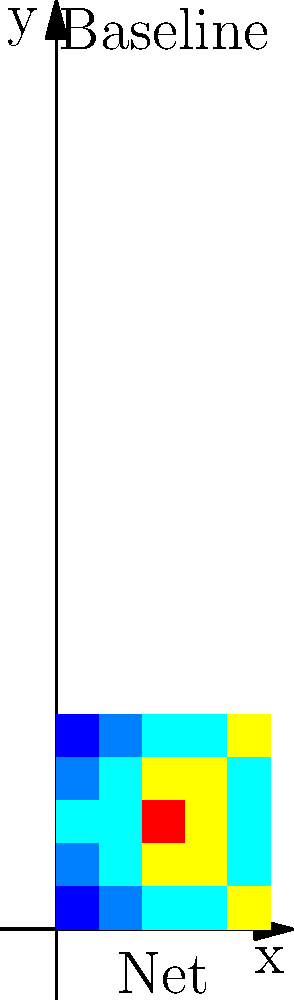Given the heat map of player movements on a badminton court, where warmer colors (red) indicate higher frequency of movement and cooler colors (blue) indicate lower frequency, what strategy would you recommend to optimize court coverage based on this data? To optimize court coverage based on the given heat map, we need to analyze the movement patterns and devise a strategy accordingly. Let's break it down step-by-step:

1. Analyze the heat map:
   - The center of the court (represented by the 3x3 square in the middle) shows the highest concentration of movement (red and yellow).
   - The front corners near the net and the back corners near the baseline show less frequent movement (light blue).

2. Interpret the data:
   - The player spends most of their time in the central area of the court.
   - There's moderate movement towards the sides of the court in the mid-court area.
   - The corners are visited less frequently.

3. Identify strengths and weaknesses:
   - Strength: Good central court coverage
   - Weakness: Potential vulnerability in the corners

4. Develop a strategy:
   a) Maintain strong central position: Since the player already covers the central area well, they should continue to return to this position after each shot.
   
   b) Improve corner coverage: Practice quick movements to the corners, especially to the front corners near the net, to cover drop shots and net plays.
   
   c) Anticipation: Develop better anticipation skills to read opponent's shots early, allowing quicker movements to less frequented areas.
   
   d) Shot selection: Use shots that allow a quick return to the central position, such as clear shots when pushed to the back corners.
   
   e) Fitness training: Focus on improving agility and speed to cover the corners more efficiently when needed.

5. Implementation:
   - Incorporate specific drills in training that focus on quick movements to and from the corners.
   - Practice match scenarios that force movement to less covered areas.
   - Regularly analyze match footage to identify and improve on areas of weak coverage.

By implementing this strategy, the player can maintain their strong central court presence while improving their ability to cover the entire court more effectively.
Answer: Maintain central position; improve corner coverage through quick movements, anticipation, and strategic shot selection; focus on agility training. 